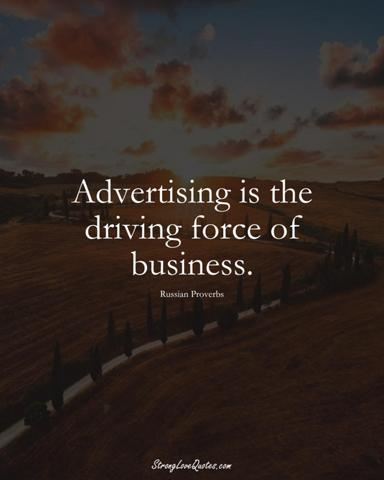Why might this proverb have been paired with an image of a road? The road represents a journey, reflecting the continuous process of business development and the progression achieved through advertising. As a driving force, advertising guides and sustains momentum just as a road directs movement. It signifies that a well-planned advertising strategy can set the direction and speed of business growth, ensuring that the business stays on the right path and reaches its envisioned destination. 